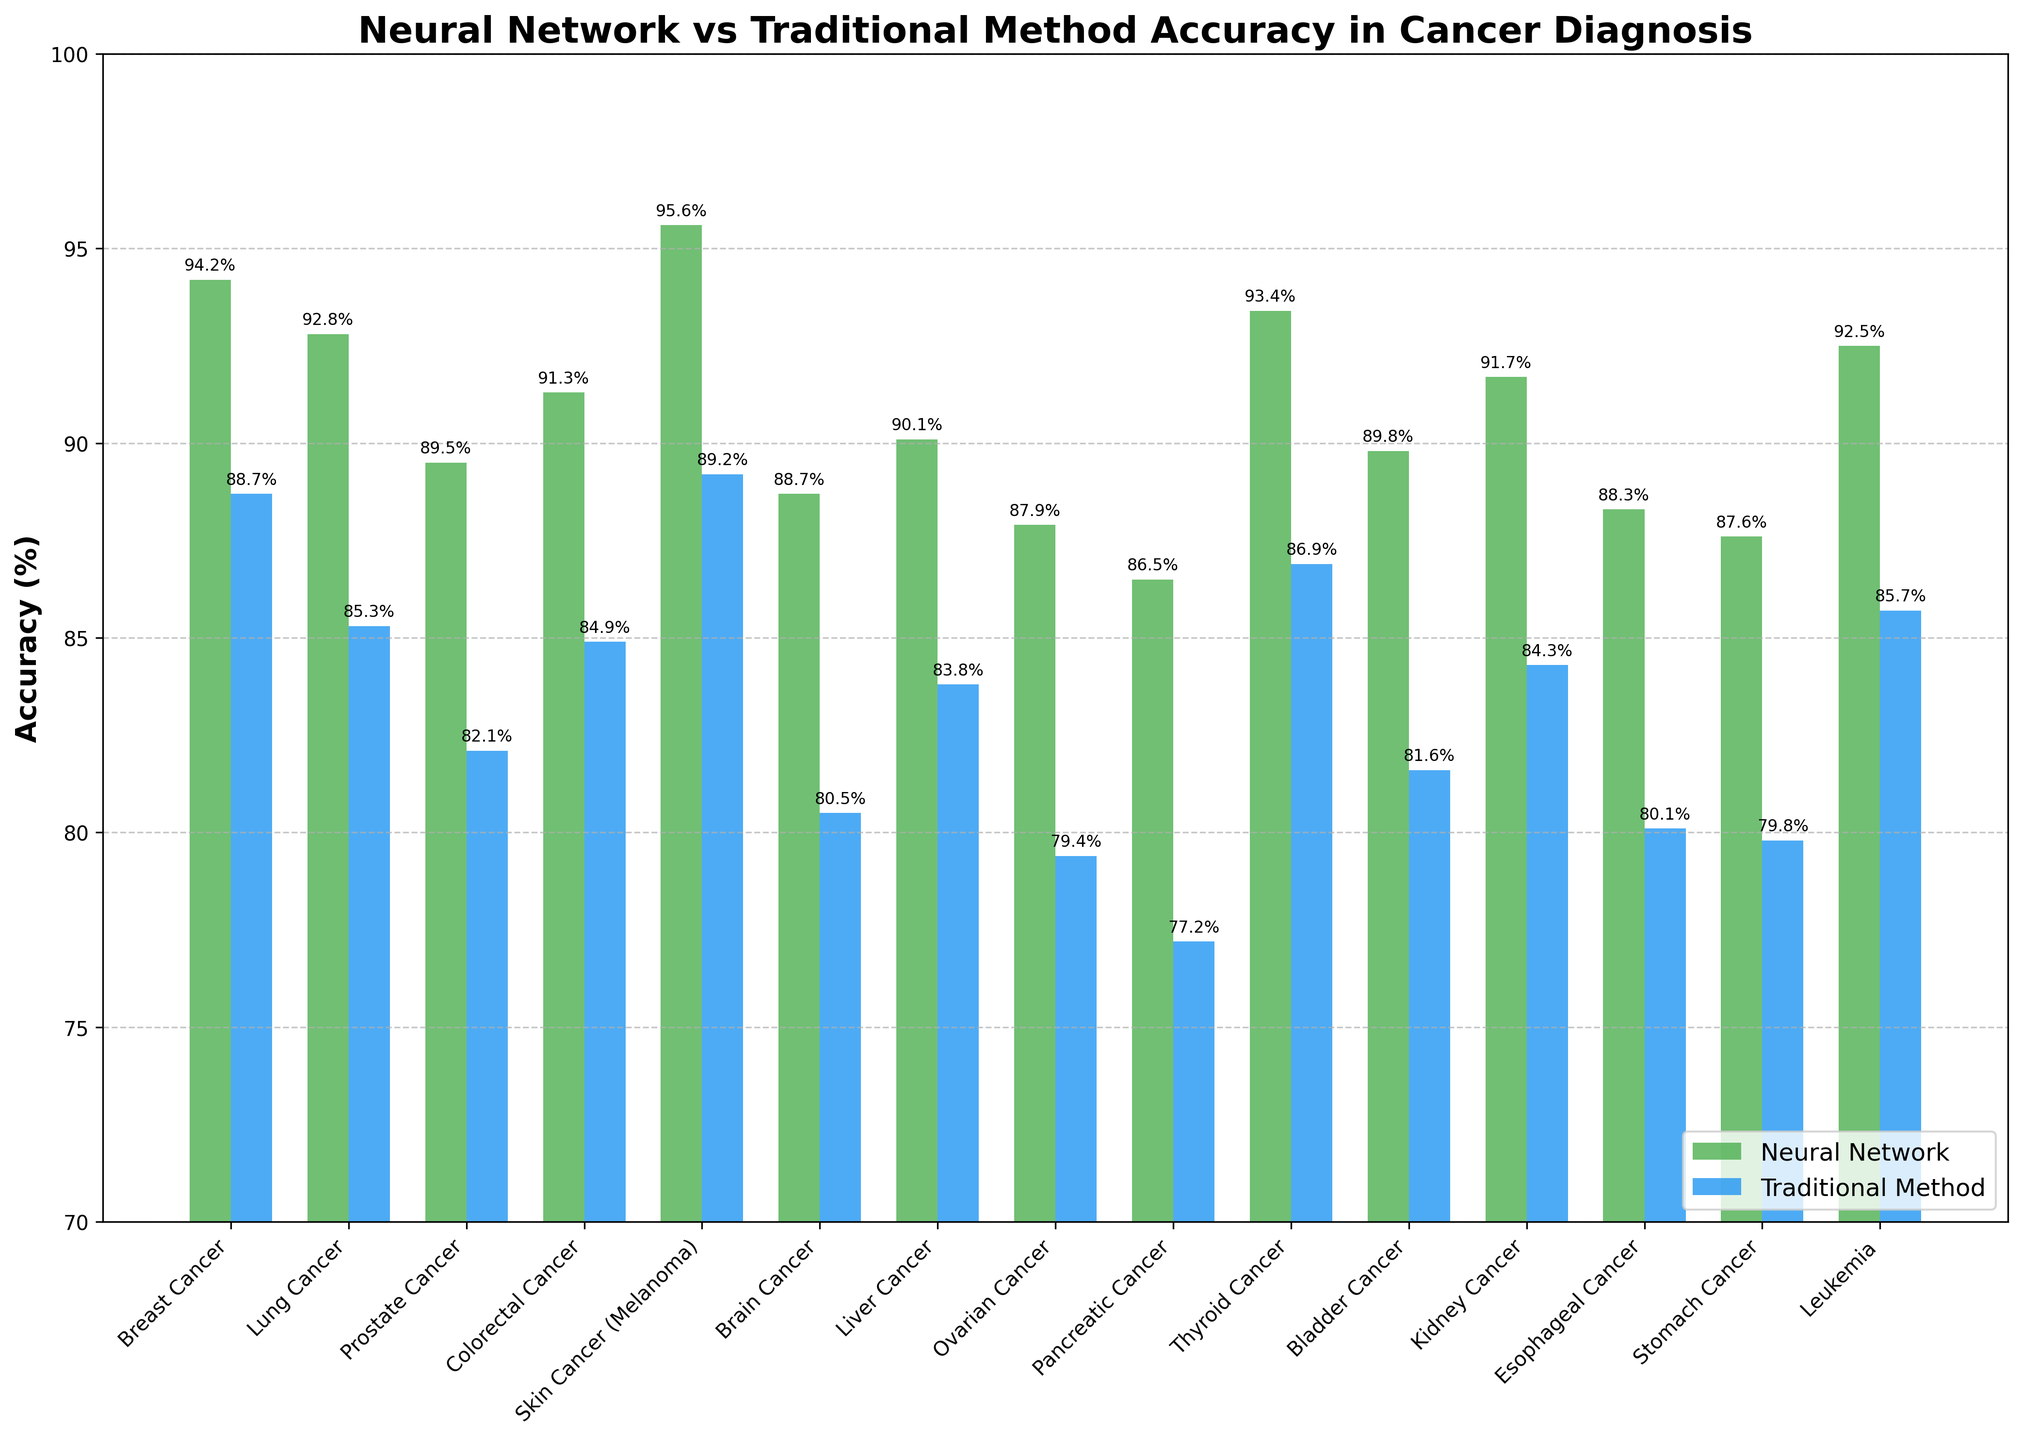Which cancer type has the highest neural network accuracy? Breast Cancer has the highest neural network accuracy at 95.6%, as seen by the tallest green bar.
Answer: Breast Cancer Which cancer type has the smallest difference in accuracy between neural network and traditional methods? Thyroid Cancer has the smallest difference in accuracy (93.4% - 86.9% = 6.5%), which can be observed by comparing the heights of the paired bars.
Answer: Thyroid Cancer What's the average neural network accuracy for diagnosing all cancers? Summing up all neural network accuracy rates: 94.2 + 92.8 + 89.5 + 91.3 + 95.6 + 88.7 + 90.1 + 87.9 + 86.5 + 93.4 + 89.8 + 91.7 + 88.3 + 87.6 + 92.5 = 1270.3. There are 15 cancer types, so the average is 1270.3 / 15 = 84.7%.
Answer: 84.7% Which cancer has the largest improvement in accuracy using the neural network over the traditional method? Pancreatic Cancer has the largest improvement with an increase of 9.3% (86.5% neural network accuracy - 77.2% traditional method accuracy).
Answer: Pancreatic Cancer What is the accuracy range for traditional methods in diagnosing these cancers? The lowest traditional method accuracy is 77.2% (Pancreatic Cancer) and the highest is 89.2% (Skin Cancer, Melanoma). The range is 89.2% - 77.2% = 12%.
Answer: 12% Which cancer types have at least a 10% higher neural network accuracy compared to traditional methods? Breast Cancer (94.2% - 88.7% = 5.5%), Lung Cancer (92.8% - 85.3% = 7.5%), Prostate Cancer (89.5% - 82.1% = 7.4%), Colorectal Cancer (91.3% - 84.9% = 6.4%), Skin Cancer (95.6% - 89.2% = 6.4%), Brain Cancer (88.7% - 80.5% = 8.2%), Liver Cancer (90.1% - 83.8% = 6.3%), Ovarian Cancer (87.9% - 79.4% = 8.5%), Pancreatic Cancer (86.5% - 77.2% = 9.3%), Thyroid Cancer (93.4% - 86.9% = 6.5%), Bladder Cancer (89.8% - 81.6% = 8.2%), Kidney Cancer (91.7% - 84.3% = 7.4%), Esophageal Cancer (88.3% - 80.1% = 8.2%), Stomach Cancer (87.6% - 79.8% = 7.8%), and Leukemia (92.5% - 85.7% = 6.8%). None of the cancers exhibit this 10+% advantage.
Answer: None 